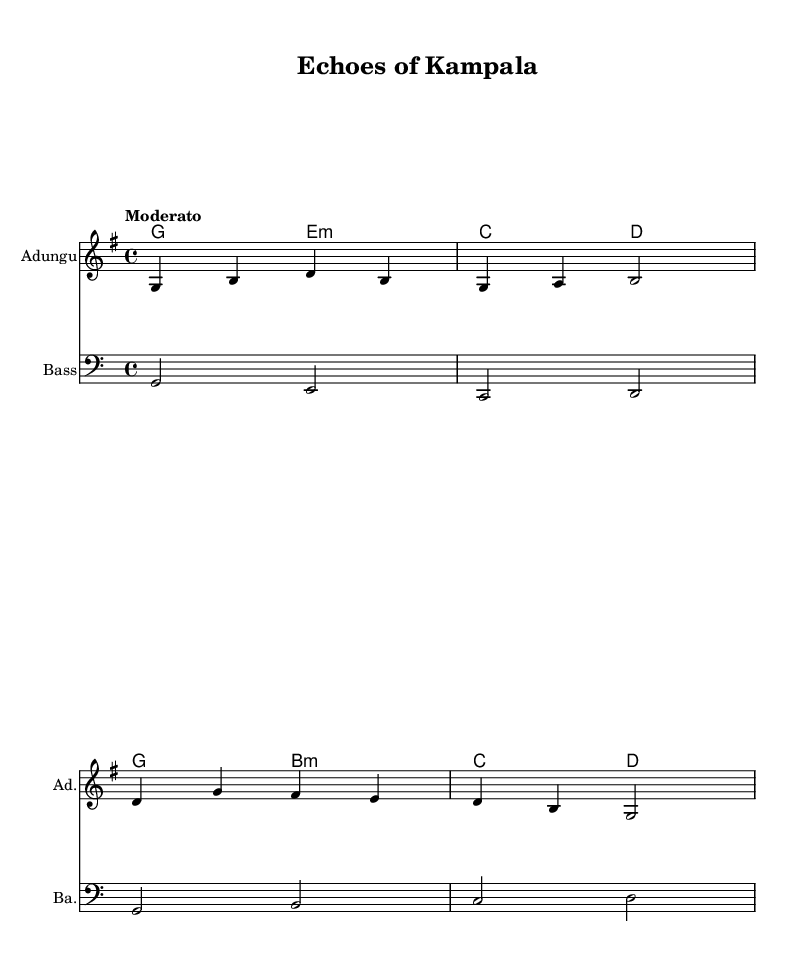What is the key signature of this music? The key signature is G major, which has one sharp (F#). This can be identified from the presence of the sharp symbol on the staff ahead of the notes.
Answer: G major What is the time signature used in this piece? The time signature is 4/4, which can be seen at the beginning of the score, indicating that there are four beats in each measure and the quarter note gets one beat.
Answer: 4/4 What is the tempo marking for this piece? The tempo marking is "Moderato," which indicates a moderate speed. This is usually found at the beginning of the score above the staff.
Answer: Moderato How many measures are in the melody? There are eight measures of melody in this piece. This can be counted by observing the horizontal divisions formed by the bar lines on the staff.
Answer: 8 What instruments are featured in this score? The instruments featured are the Adungu and Bass. This information is indicated above each staff at the beginning of the score, which names the instruments playing the music.
Answer: Adungu, Bass What chord progression is primarily used? The primary chord progression is G, E minor, C, D. This can be deduced from the chord symbols written above the melody, indicating the chords that accompany the melody in order.
Answer: G, E minor, C, D 